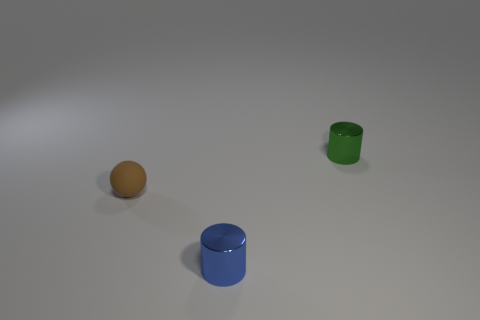How many objects are yellow rubber cubes or tiny cylinders that are in front of the brown ball?
Offer a very short reply. 1. Is there any other thing that has the same shape as the tiny green thing?
Offer a very short reply. Yes. What number of metal objects are cylinders or tiny objects?
Offer a terse response. 2. What is the size of the object on the right side of the blue shiny object?
Keep it short and to the point. Small. Do the brown rubber object and the tiny blue object have the same shape?
Give a very brief answer. No. What number of small objects are green metallic things or cylinders?
Your response must be concise. 2. Are there any tiny matte spheres to the right of the small blue metallic cylinder?
Your answer should be compact. No. Is the number of blue shiny objects that are behind the matte object the same as the number of tiny balls?
Your response must be concise. No. What size is the other metallic thing that is the same shape as the green metal thing?
Your response must be concise. Small. Does the small green metallic object have the same shape as the brown object behind the tiny blue thing?
Your response must be concise. No. 